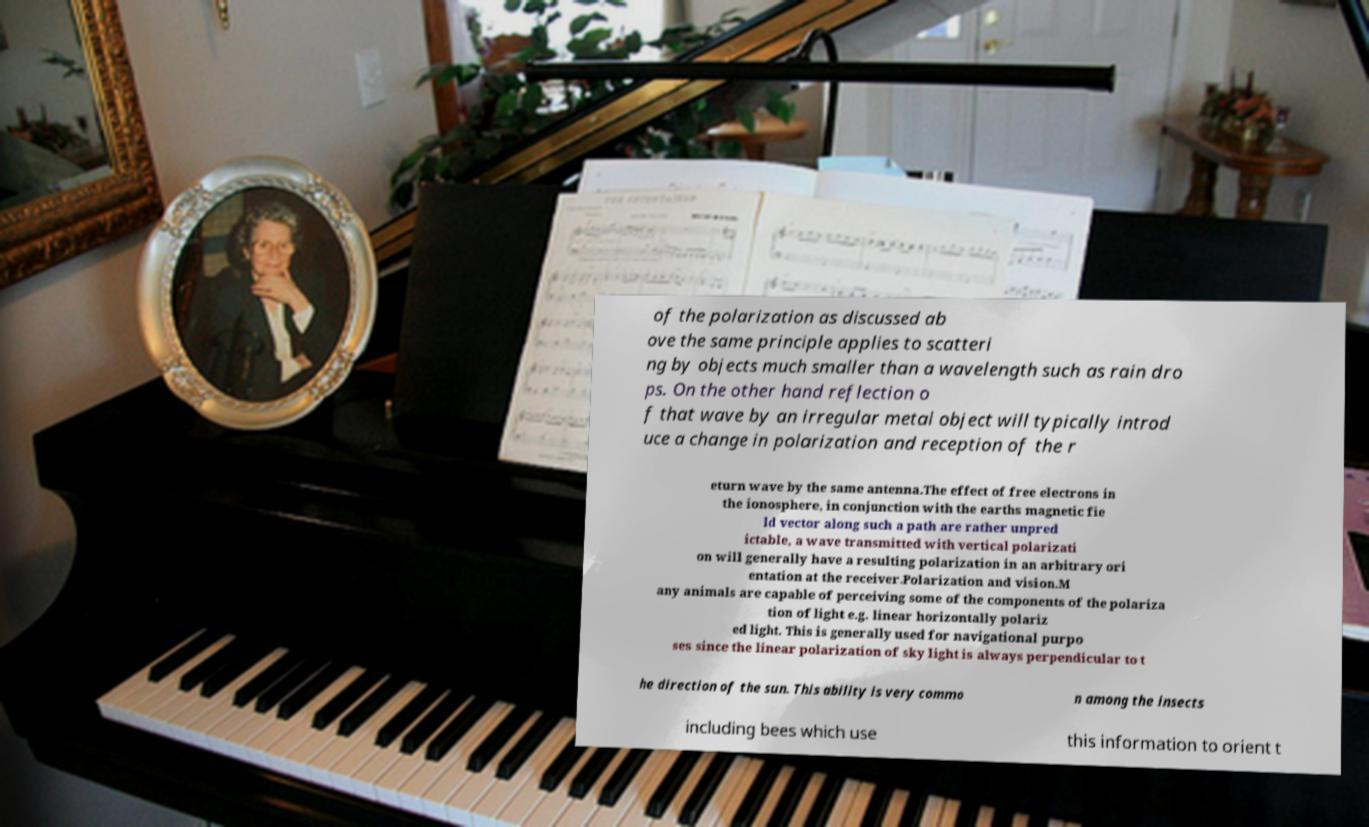Please read and relay the text visible in this image. What does it say? of the polarization as discussed ab ove the same principle applies to scatteri ng by objects much smaller than a wavelength such as rain dro ps. On the other hand reflection o f that wave by an irregular metal object will typically introd uce a change in polarization and reception of the r eturn wave by the same antenna.The effect of free electrons in the ionosphere, in conjunction with the earths magnetic fie ld vector along such a path are rather unpred ictable, a wave transmitted with vertical polarizati on will generally have a resulting polarization in an arbitrary ori entation at the receiver.Polarization and vision.M any animals are capable of perceiving some of the components of the polariza tion of light e.g. linear horizontally polariz ed light. This is generally used for navigational purpo ses since the linear polarization of sky light is always perpendicular to t he direction of the sun. This ability is very commo n among the insects including bees which use this information to orient t 